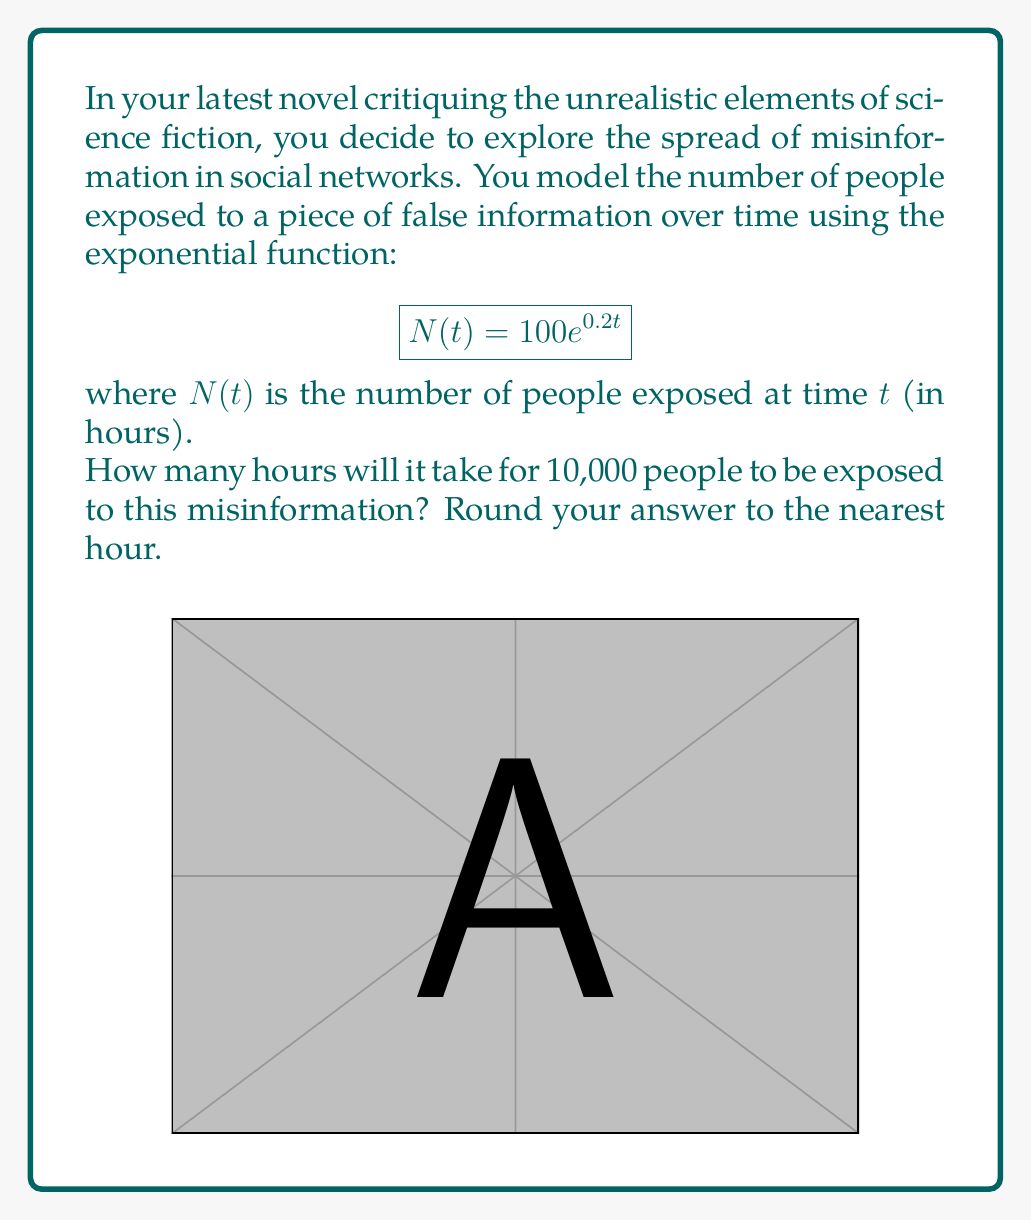Help me with this question. Let's approach this step-by-step:

1) We want to find $t$ when $N(t) = 10,000$. So, we need to solve the equation:

   $$10000 = 100e^{0.2t}$$

2) Divide both sides by 100:

   $$100 = e^{0.2t}$$

3) Take the natural logarithm of both sides:

   $$\ln(100) = \ln(e^{0.2t})$$

4) Simplify the right side using the property of logarithms:

   $$\ln(100) = 0.2t$$

5) Solve for $t$:

   $$t = \frac{\ln(100)}{0.2}$$

6) Calculate:

   $$t = \frac{4.60517}{0.2} = 23.02585$$

7) Rounding to the nearest hour:

   $$t \approx 23 \text{ hours}$$

This realistic model shows how quickly misinformation can spread, highlighting a genuine concern in our interconnected world.
Answer: 23 hours 